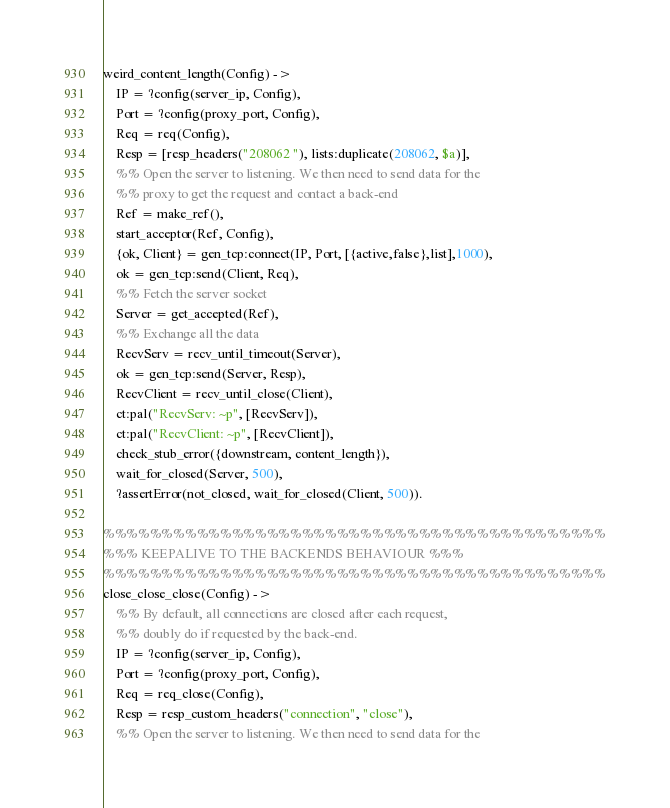Convert code to text. <code><loc_0><loc_0><loc_500><loc_500><_Erlang_>weird_content_length(Config) ->
    IP = ?config(server_ip, Config),
    Port = ?config(proxy_port, Config),
    Req = req(Config),
    Resp = [resp_headers("208062 "), lists:duplicate(208062, $a)],
    %% Open the server to listening. We then need to send data for the
    %% proxy to get the request and contact a back-end
    Ref = make_ref(),
    start_acceptor(Ref, Config),
    {ok, Client} = gen_tcp:connect(IP, Port, [{active,false},list],1000),
    ok = gen_tcp:send(Client, Req),
    %% Fetch the server socket
    Server = get_accepted(Ref),
    %% Exchange all the data
    RecvServ = recv_until_timeout(Server),
    ok = gen_tcp:send(Server, Resp),
    RecvClient = recv_until_close(Client),
    ct:pal("RecvServ: ~p", [RecvServ]),
    ct:pal("RecvClient: ~p", [RecvClient]),
    check_stub_error({downstream, content_length}),
    wait_for_closed(Server, 500),
    ?assertError(not_closed, wait_for_closed(Client, 500)).

%%%%%%%%%%%%%%%%%%%%%%%%%%%%%%%%%%%%%%%%%%%
%%% KEEPALIVE TO THE BACKENDS BEHAVIOUR %%%
%%%%%%%%%%%%%%%%%%%%%%%%%%%%%%%%%%%%%%%%%%%
close_close_close(Config) ->
    %% By default, all connections are closed after each request,
    %% doubly do if requested by the back-end.
    IP = ?config(server_ip, Config),
    Port = ?config(proxy_port, Config),
    Req = req_close(Config),
    Resp = resp_custom_headers("connection", "close"),
    %% Open the server to listening. We then need to send data for the</code> 